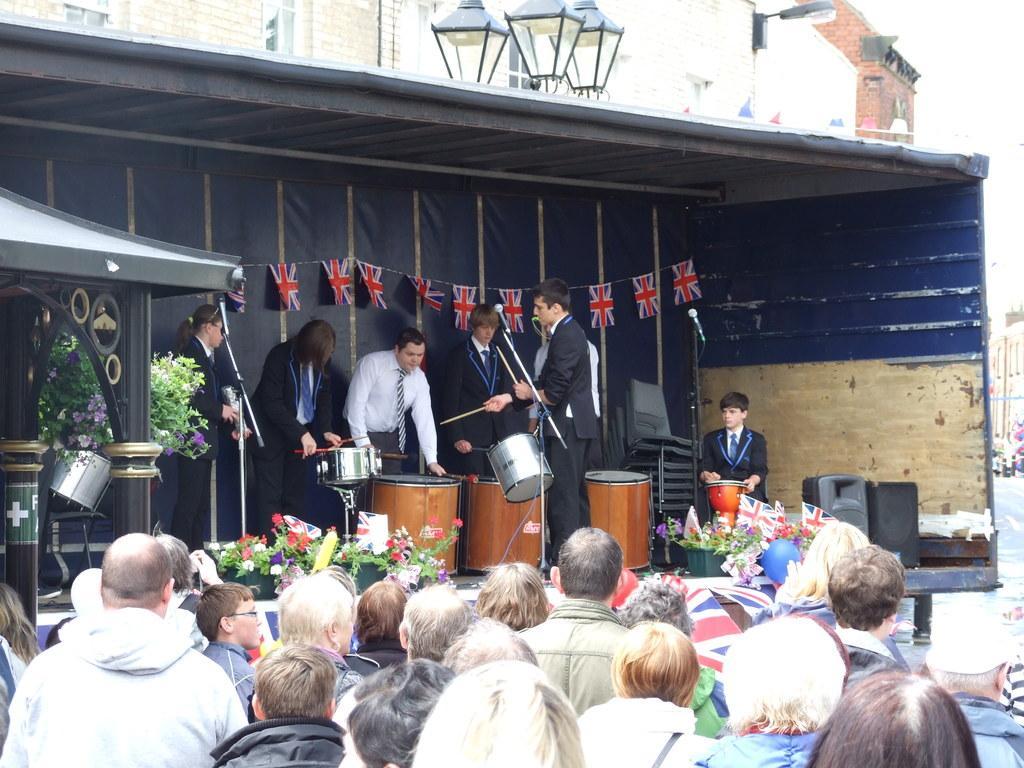Please provide a concise description of this image. In this image, in the middle, we can see a group of people are standing in front of the musical instrument. In the middle of the image, we can see a person wearing a musical instrument and holding two sticks in his hand. On the right side, we can also see a boy sitting in front of the musical instrument. On the left side, we can see some musical instrument, pillar. In the background, we can also see some flags, street lights, building. At the bottom, we can see a group of people and speakers. 